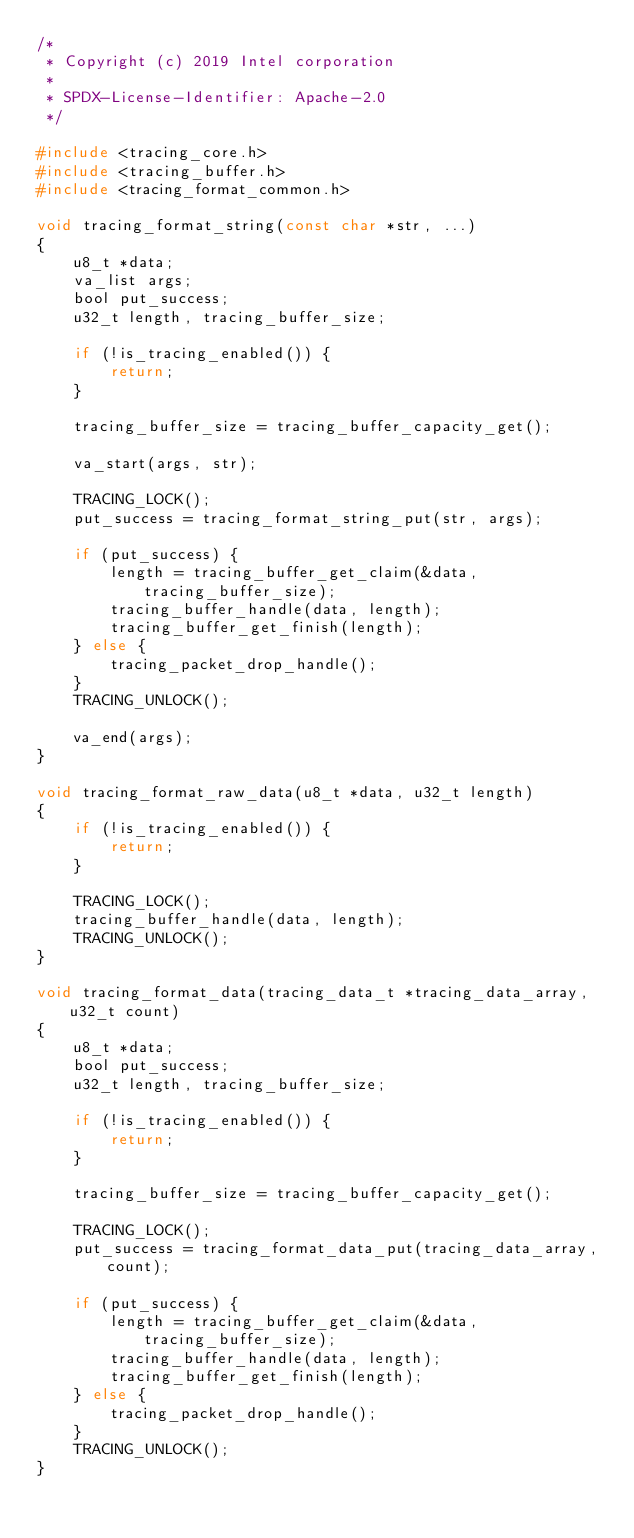<code> <loc_0><loc_0><loc_500><loc_500><_C_>/*
 * Copyright (c) 2019 Intel corporation
 *
 * SPDX-License-Identifier: Apache-2.0
 */

#include <tracing_core.h>
#include <tracing_buffer.h>
#include <tracing_format_common.h>

void tracing_format_string(const char *str, ...)
{
	u8_t *data;
	va_list args;
	bool put_success;
	u32_t length, tracing_buffer_size;

	if (!is_tracing_enabled()) {
		return;
	}

	tracing_buffer_size = tracing_buffer_capacity_get();

	va_start(args, str);

	TRACING_LOCK();
	put_success = tracing_format_string_put(str, args);

	if (put_success) {
		length = tracing_buffer_get_claim(&data, tracing_buffer_size);
		tracing_buffer_handle(data, length);
		tracing_buffer_get_finish(length);
	} else {
		tracing_packet_drop_handle();
	}
	TRACING_UNLOCK();

	va_end(args);
}

void tracing_format_raw_data(u8_t *data, u32_t length)
{
	if (!is_tracing_enabled()) {
		return;
	}

	TRACING_LOCK();
	tracing_buffer_handle(data, length);
	TRACING_UNLOCK();
}

void tracing_format_data(tracing_data_t *tracing_data_array, u32_t count)
{
	u8_t *data;
	bool put_success;
	u32_t length, tracing_buffer_size;

	if (!is_tracing_enabled()) {
		return;
	}

	tracing_buffer_size = tracing_buffer_capacity_get();

	TRACING_LOCK();
	put_success = tracing_format_data_put(tracing_data_array, count);

	if (put_success) {
		length = tracing_buffer_get_claim(&data, tracing_buffer_size);
		tracing_buffer_handle(data, length);
		tracing_buffer_get_finish(length);
	} else {
		tracing_packet_drop_handle();
	}
	TRACING_UNLOCK();
}
</code> 